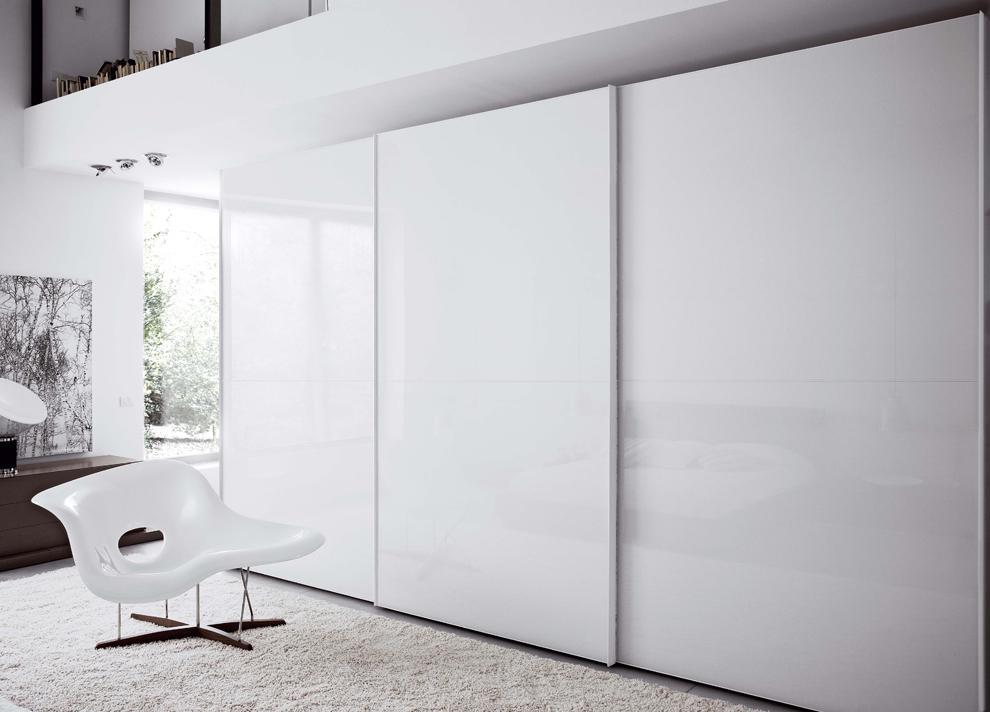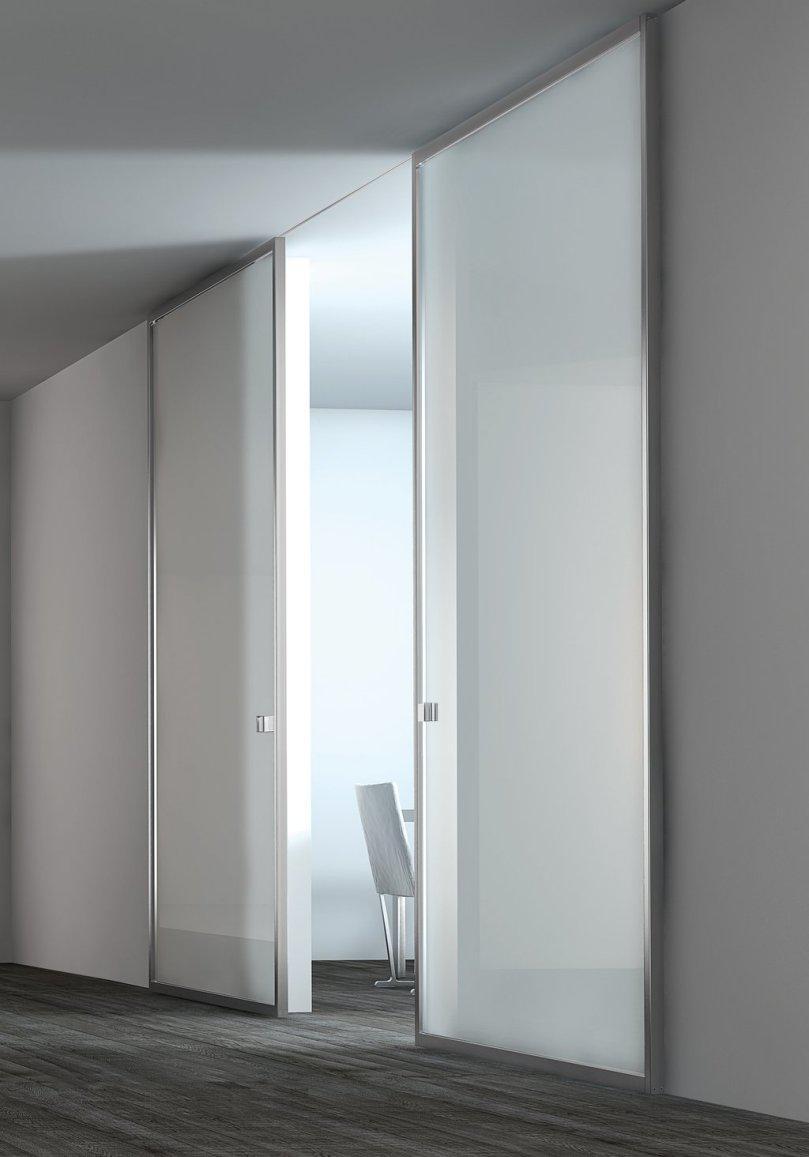The first image is the image on the left, the second image is the image on the right. For the images shown, is this caption "An image shows a two door dimensional unit with a white front." true? Answer yes or no. No. 